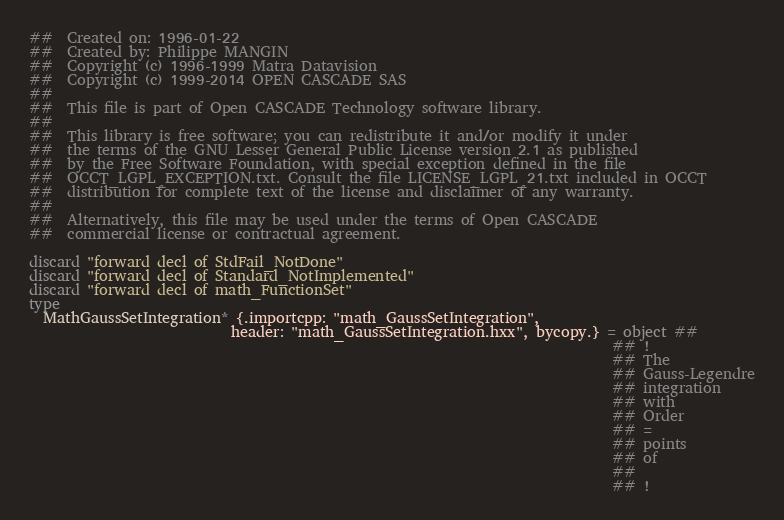Convert code to text. <code><loc_0><loc_0><loc_500><loc_500><_Nim_>##  Created on: 1996-01-22
##  Created by: Philippe MANGIN
##  Copyright (c) 1996-1999 Matra Datavision
##  Copyright (c) 1999-2014 OPEN CASCADE SAS
##
##  This file is part of Open CASCADE Technology software library.
##
##  This library is free software; you can redistribute it and/or modify it under
##  the terms of the GNU Lesser General Public License version 2.1 as published
##  by the Free Software Foundation, with special exception defined in the file
##  OCCT_LGPL_EXCEPTION.txt. Consult the file LICENSE_LGPL_21.txt included in OCCT
##  distribution for complete text of the license and disclaimer of any warranty.
##
##  Alternatively, this file may be used under the terms of Open CASCADE
##  commercial license or contractual agreement.

discard "forward decl of StdFail_NotDone"
discard "forward decl of Standard_NotImplemented"
discard "forward decl of math_FunctionSet"
type
  MathGaussSetIntegration* {.importcpp: "math_GaussSetIntegration",
                            header: "math_GaussSetIntegration.hxx", bycopy.} = object ##
                                                                                 ## !
                                                                                 ## The
                                                                                 ## Gauss-Legendre
                                                                                 ## integration
                                                                                 ## with
                                                                                 ## Order
                                                                                 ## =
                                                                                 ## points
                                                                                 ## of
                                                                                 ##
                                                                                 ## !</code> 